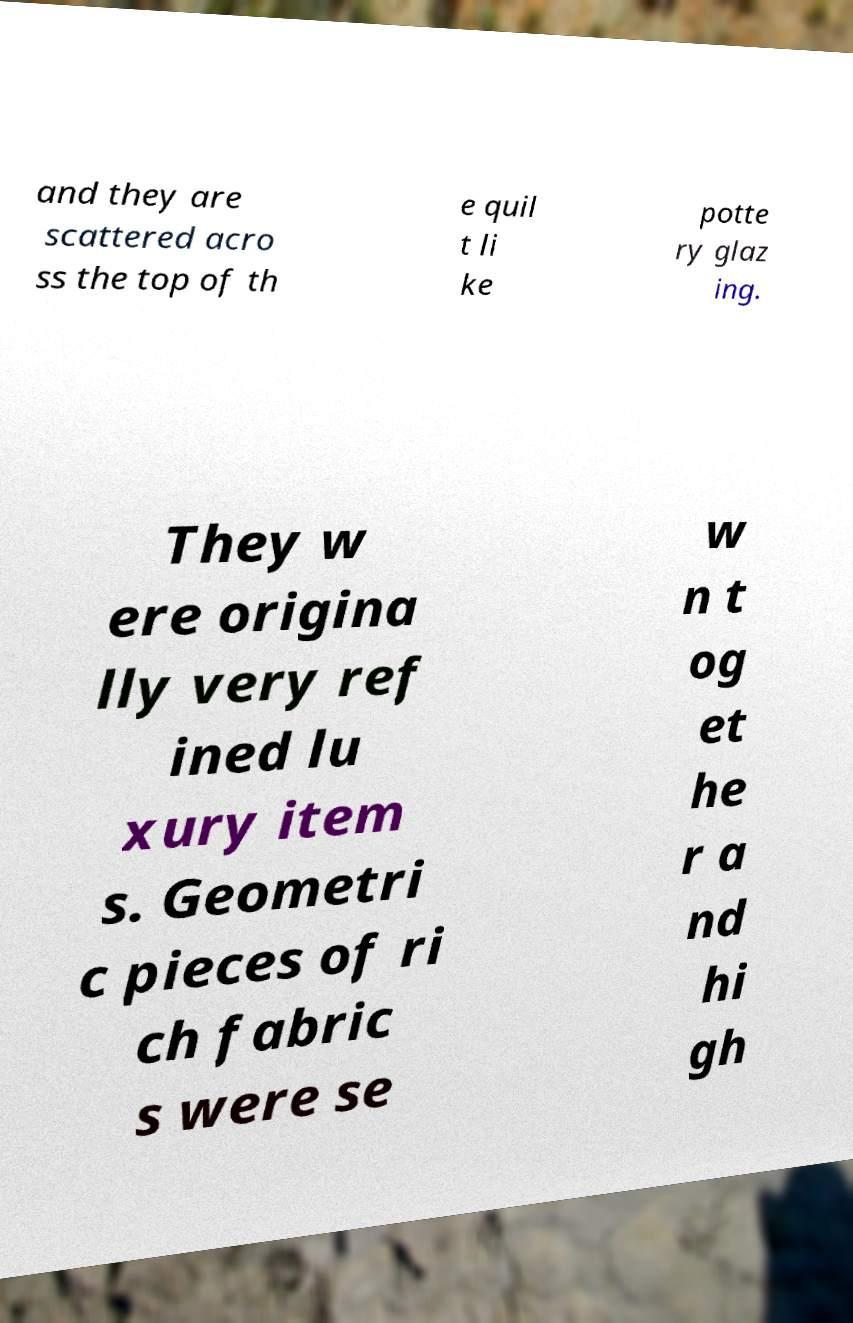For documentation purposes, I need the text within this image transcribed. Could you provide that? and they are scattered acro ss the top of th e quil t li ke potte ry glaz ing. They w ere origina lly very ref ined lu xury item s. Geometri c pieces of ri ch fabric s were se w n t og et he r a nd hi gh 